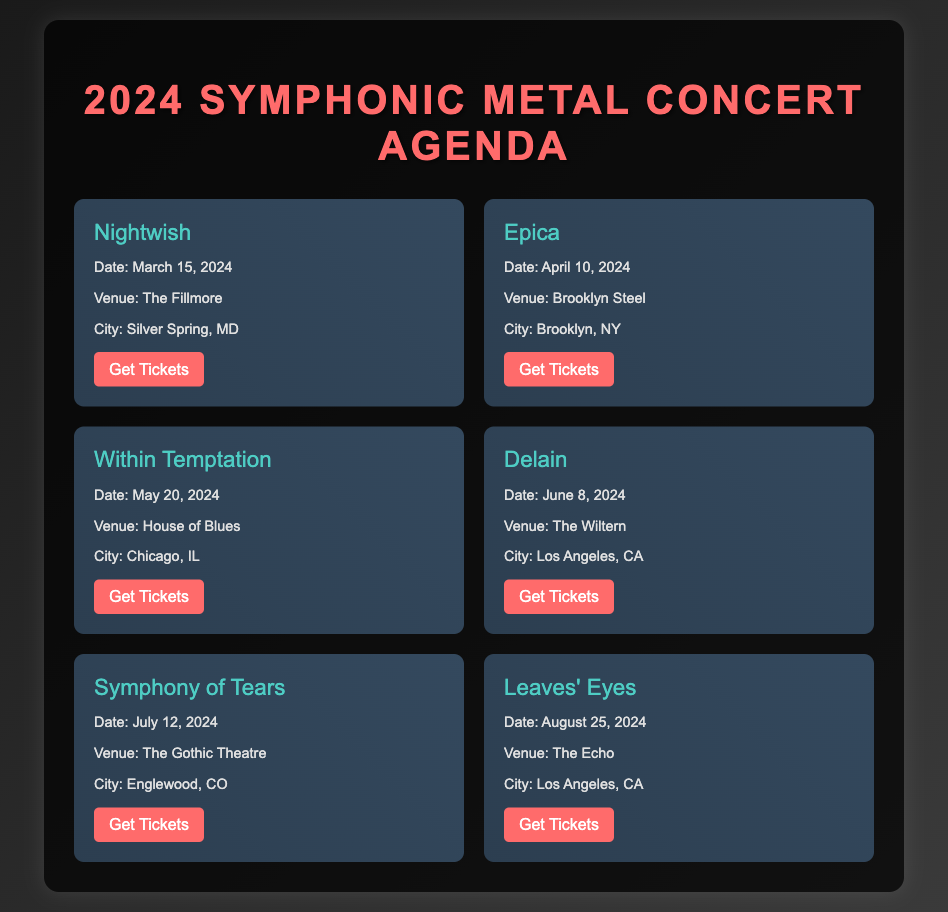What is the name of the first band on the agenda? The first band listed in the document is Nightwish.
Answer: Nightwish What is the date of the concert for Epica? The concert date for Epica is April 10, 2024, as mentioned in the details.
Answer: April 10, 2024 Which city will the Symphony of Tears perform in? The document states that Symphony of Tears will perform in Englewood, CO.
Answer: Englewood, CO How many concerts are scheduled in July 2024? There is one concert listed in July 2024, specifically for Symphony of Tears.
Answer: 1 What venue is hosting Leaves' Eyes? The document shows Leaves' Eyes performing at The Echo.
Answer: The Echo Which concert is taking place in Chicago? The concert in Chicago is by Within Temptation, according to the venue information.
Answer: Within Temptation What is the ticket link for Delain? The ticket link for Delain is specified as https://www.livenation.com/event/13311 in the details.
Answer: https://www.livenation.com/event/13311 Which band has a concert in Los Angeles in June? According to the document, Delain has a concert scheduled in Los Angeles in June 2024.
Answer: Delain What color is used for the band names in the document? The band names are styled in a color specified as 4ecdc4 in the CSS.
Answer: 4ecdc4 